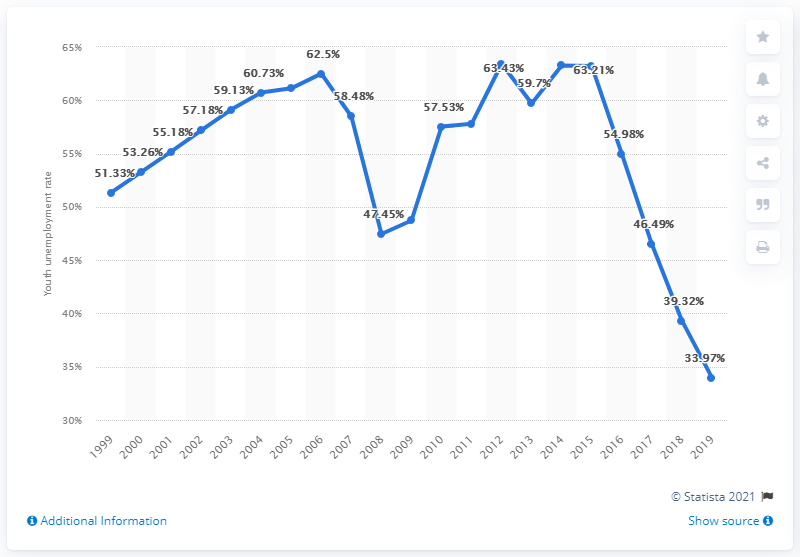Draw attention to some important aspects in this diagram. The youth unemployment rate in Bosnia and Herzegovina in 2019 was 33.97%. 